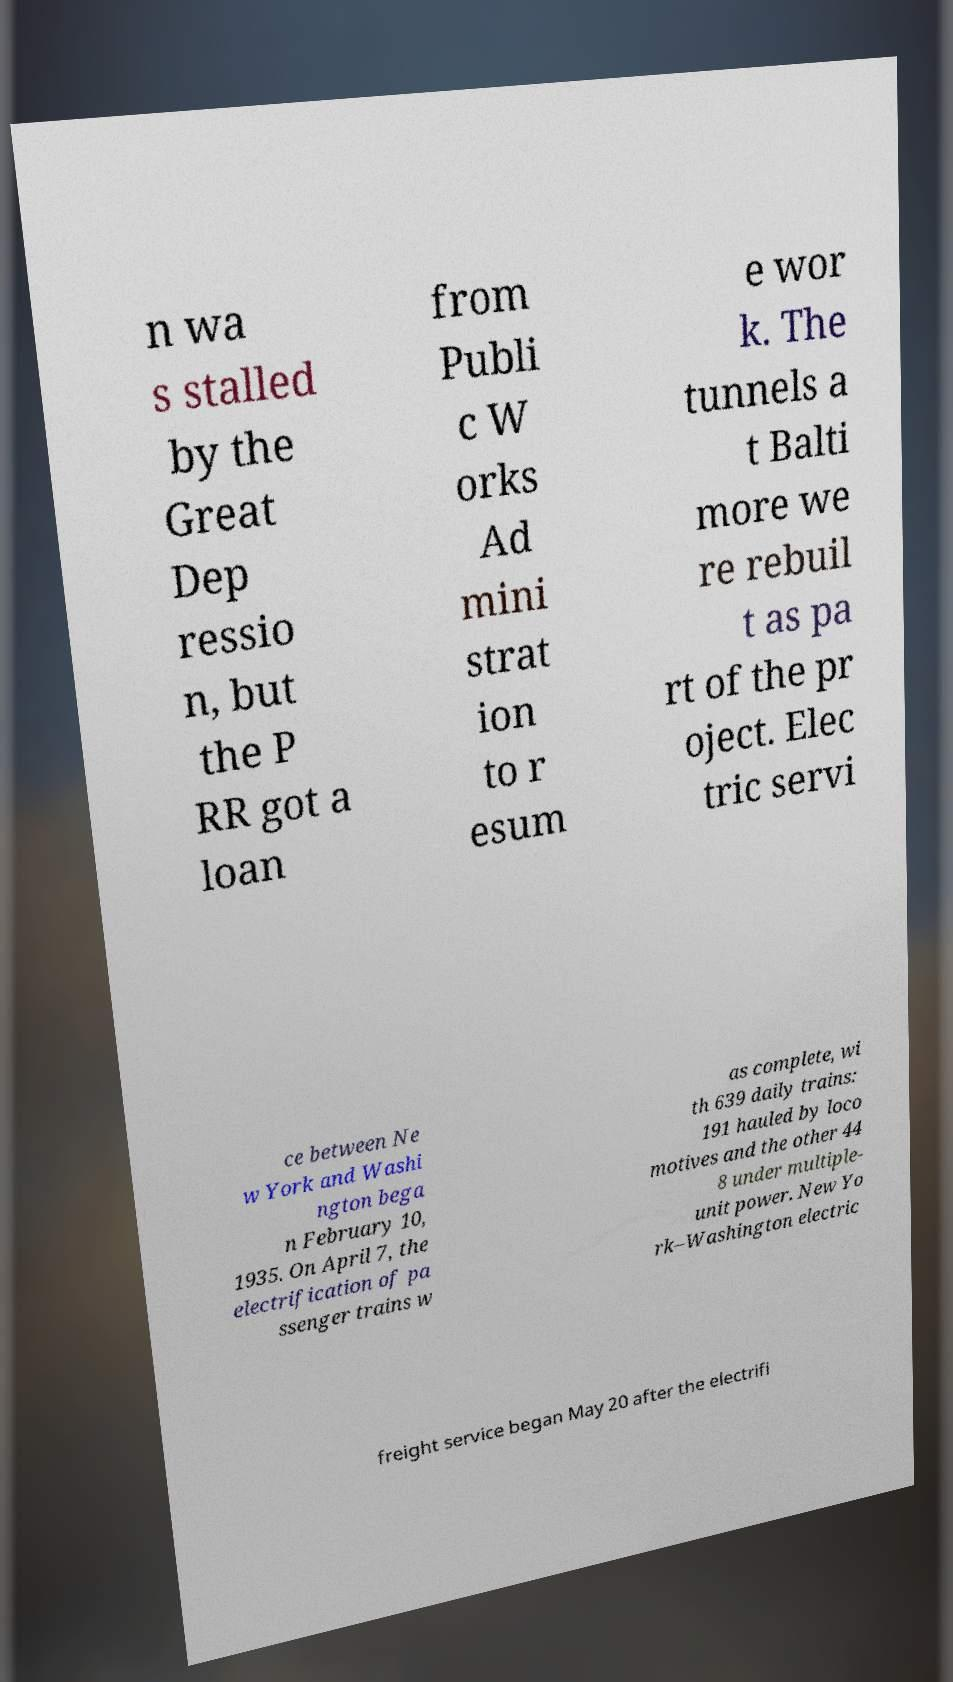What messages or text are displayed in this image? I need them in a readable, typed format. n wa s stalled by the Great Dep ressio n, but the P RR got a loan from Publi c W orks Ad mini strat ion to r esum e wor k. The tunnels a t Balti more we re rebuil t as pa rt of the pr oject. Elec tric servi ce between Ne w York and Washi ngton bega n February 10, 1935. On April 7, the electrification of pa ssenger trains w as complete, wi th 639 daily trains: 191 hauled by loco motives and the other 44 8 under multiple- unit power. New Yo rk–Washington electric freight service began May 20 after the electrifi 